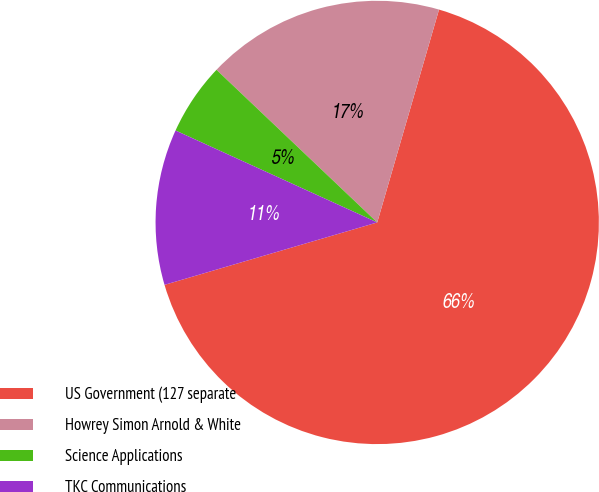Convert chart. <chart><loc_0><loc_0><loc_500><loc_500><pie_chart><fcel>US Government (127 separate<fcel>Howrey Simon Arnold & White<fcel>Science Applications<fcel>TKC Communications<nl><fcel>65.96%<fcel>17.41%<fcel>5.28%<fcel>11.35%<nl></chart> 